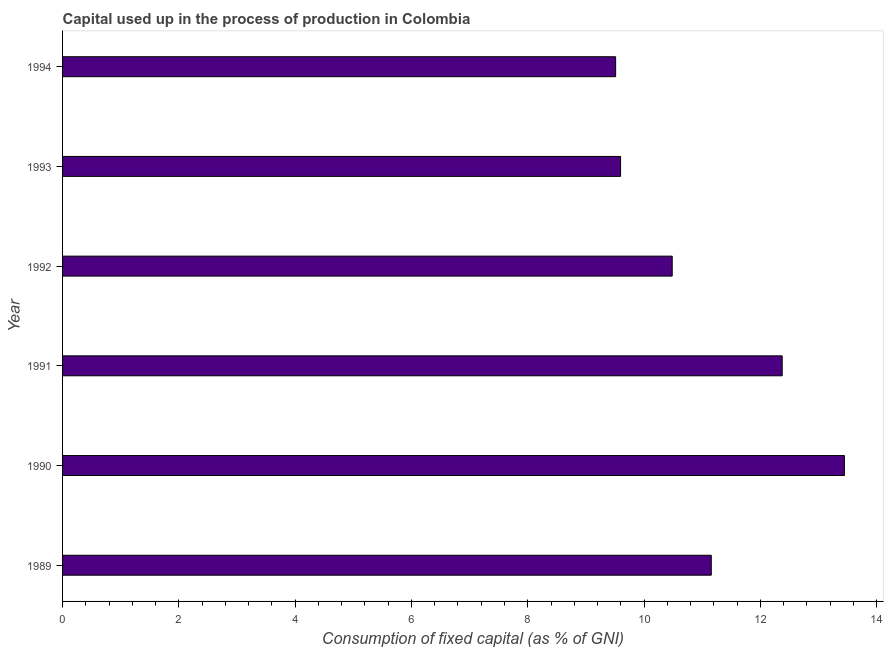What is the title of the graph?
Ensure brevity in your answer.  Capital used up in the process of production in Colombia. What is the label or title of the X-axis?
Offer a very short reply. Consumption of fixed capital (as % of GNI). What is the label or title of the Y-axis?
Provide a succinct answer. Year. What is the consumption of fixed capital in 1989?
Your response must be concise. 11.16. Across all years, what is the maximum consumption of fixed capital?
Provide a short and direct response. 13.45. Across all years, what is the minimum consumption of fixed capital?
Give a very brief answer. 9.51. In which year was the consumption of fixed capital maximum?
Provide a short and direct response. 1990. What is the sum of the consumption of fixed capital?
Offer a very short reply. 66.57. What is the difference between the consumption of fixed capital in 1989 and 1992?
Provide a succinct answer. 0.67. What is the average consumption of fixed capital per year?
Offer a terse response. 11.1. What is the median consumption of fixed capital?
Offer a terse response. 10.82. What is the ratio of the consumption of fixed capital in 1989 to that in 1993?
Your response must be concise. 1.16. Is the consumption of fixed capital in 1989 less than that in 1993?
Your answer should be compact. No. Is the difference between the consumption of fixed capital in 1991 and 1993 greater than the difference between any two years?
Offer a very short reply. No. What is the difference between the highest and the second highest consumption of fixed capital?
Give a very brief answer. 1.07. Is the sum of the consumption of fixed capital in 1990 and 1991 greater than the maximum consumption of fixed capital across all years?
Offer a very short reply. Yes. What is the difference between the highest and the lowest consumption of fixed capital?
Provide a short and direct response. 3.93. In how many years, is the consumption of fixed capital greater than the average consumption of fixed capital taken over all years?
Offer a terse response. 3. How many bars are there?
Your answer should be very brief. 6. Are all the bars in the graph horizontal?
Provide a short and direct response. Yes. How many years are there in the graph?
Keep it short and to the point. 6. Are the values on the major ticks of X-axis written in scientific E-notation?
Your response must be concise. No. What is the Consumption of fixed capital (as % of GNI) of 1989?
Your answer should be compact. 11.16. What is the Consumption of fixed capital (as % of GNI) in 1990?
Ensure brevity in your answer.  13.45. What is the Consumption of fixed capital (as % of GNI) in 1991?
Offer a terse response. 12.38. What is the Consumption of fixed capital (as % of GNI) in 1992?
Keep it short and to the point. 10.48. What is the Consumption of fixed capital (as % of GNI) in 1993?
Provide a succinct answer. 9.6. What is the Consumption of fixed capital (as % of GNI) in 1994?
Your response must be concise. 9.51. What is the difference between the Consumption of fixed capital (as % of GNI) in 1989 and 1990?
Keep it short and to the point. -2.29. What is the difference between the Consumption of fixed capital (as % of GNI) in 1989 and 1991?
Provide a succinct answer. -1.22. What is the difference between the Consumption of fixed capital (as % of GNI) in 1989 and 1992?
Give a very brief answer. 0.67. What is the difference between the Consumption of fixed capital (as % of GNI) in 1989 and 1993?
Give a very brief answer. 1.56. What is the difference between the Consumption of fixed capital (as % of GNI) in 1989 and 1994?
Give a very brief answer. 1.64. What is the difference between the Consumption of fixed capital (as % of GNI) in 1990 and 1991?
Provide a short and direct response. 1.07. What is the difference between the Consumption of fixed capital (as % of GNI) in 1990 and 1992?
Keep it short and to the point. 2.96. What is the difference between the Consumption of fixed capital (as % of GNI) in 1990 and 1993?
Provide a short and direct response. 3.85. What is the difference between the Consumption of fixed capital (as % of GNI) in 1990 and 1994?
Your answer should be compact. 3.93. What is the difference between the Consumption of fixed capital (as % of GNI) in 1991 and 1992?
Provide a succinct answer. 1.89. What is the difference between the Consumption of fixed capital (as % of GNI) in 1991 and 1993?
Provide a succinct answer. 2.78. What is the difference between the Consumption of fixed capital (as % of GNI) in 1991 and 1994?
Provide a short and direct response. 2.86. What is the difference between the Consumption of fixed capital (as % of GNI) in 1992 and 1993?
Your response must be concise. 0.89. What is the difference between the Consumption of fixed capital (as % of GNI) in 1992 and 1994?
Your answer should be compact. 0.97. What is the difference between the Consumption of fixed capital (as % of GNI) in 1993 and 1994?
Keep it short and to the point. 0.09. What is the ratio of the Consumption of fixed capital (as % of GNI) in 1989 to that in 1990?
Offer a terse response. 0.83. What is the ratio of the Consumption of fixed capital (as % of GNI) in 1989 to that in 1991?
Your answer should be compact. 0.9. What is the ratio of the Consumption of fixed capital (as % of GNI) in 1989 to that in 1992?
Offer a very short reply. 1.06. What is the ratio of the Consumption of fixed capital (as % of GNI) in 1989 to that in 1993?
Your response must be concise. 1.16. What is the ratio of the Consumption of fixed capital (as % of GNI) in 1989 to that in 1994?
Make the answer very short. 1.17. What is the ratio of the Consumption of fixed capital (as % of GNI) in 1990 to that in 1991?
Provide a succinct answer. 1.09. What is the ratio of the Consumption of fixed capital (as % of GNI) in 1990 to that in 1992?
Give a very brief answer. 1.28. What is the ratio of the Consumption of fixed capital (as % of GNI) in 1990 to that in 1993?
Keep it short and to the point. 1.4. What is the ratio of the Consumption of fixed capital (as % of GNI) in 1990 to that in 1994?
Provide a succinct answer. 1.41. What is the ratio of the Consumption of fixed capital (as % of GNI) in 1991 to that in 1992?
Make the answer very short. 1.18. What is the ratio of the Consumption of fixed capital (as % of GNI) in 1991 to that in 1993?
Keep it short and to the point. 1.29. What is the ratio of the Consumption of fixed capital (as % of GNI) in 1991 to that in 1994?
Your answer should be very brief. 1.3. What is the ratio of the Consumption of fixed capital (as % of GNI) in 1992 to that in 1993?
Provide a succinct answer. 1.09. What is the ratio of the Consumption of fixed capital (as % of GNI) in 1992 to that in 1994?
Your response must be concise. 1.1. What is the ratio of the Consumption of fixed capital (as % of GNI) in 1993 to that in 1994?
Ensure brevity in your answer.  1.01. 